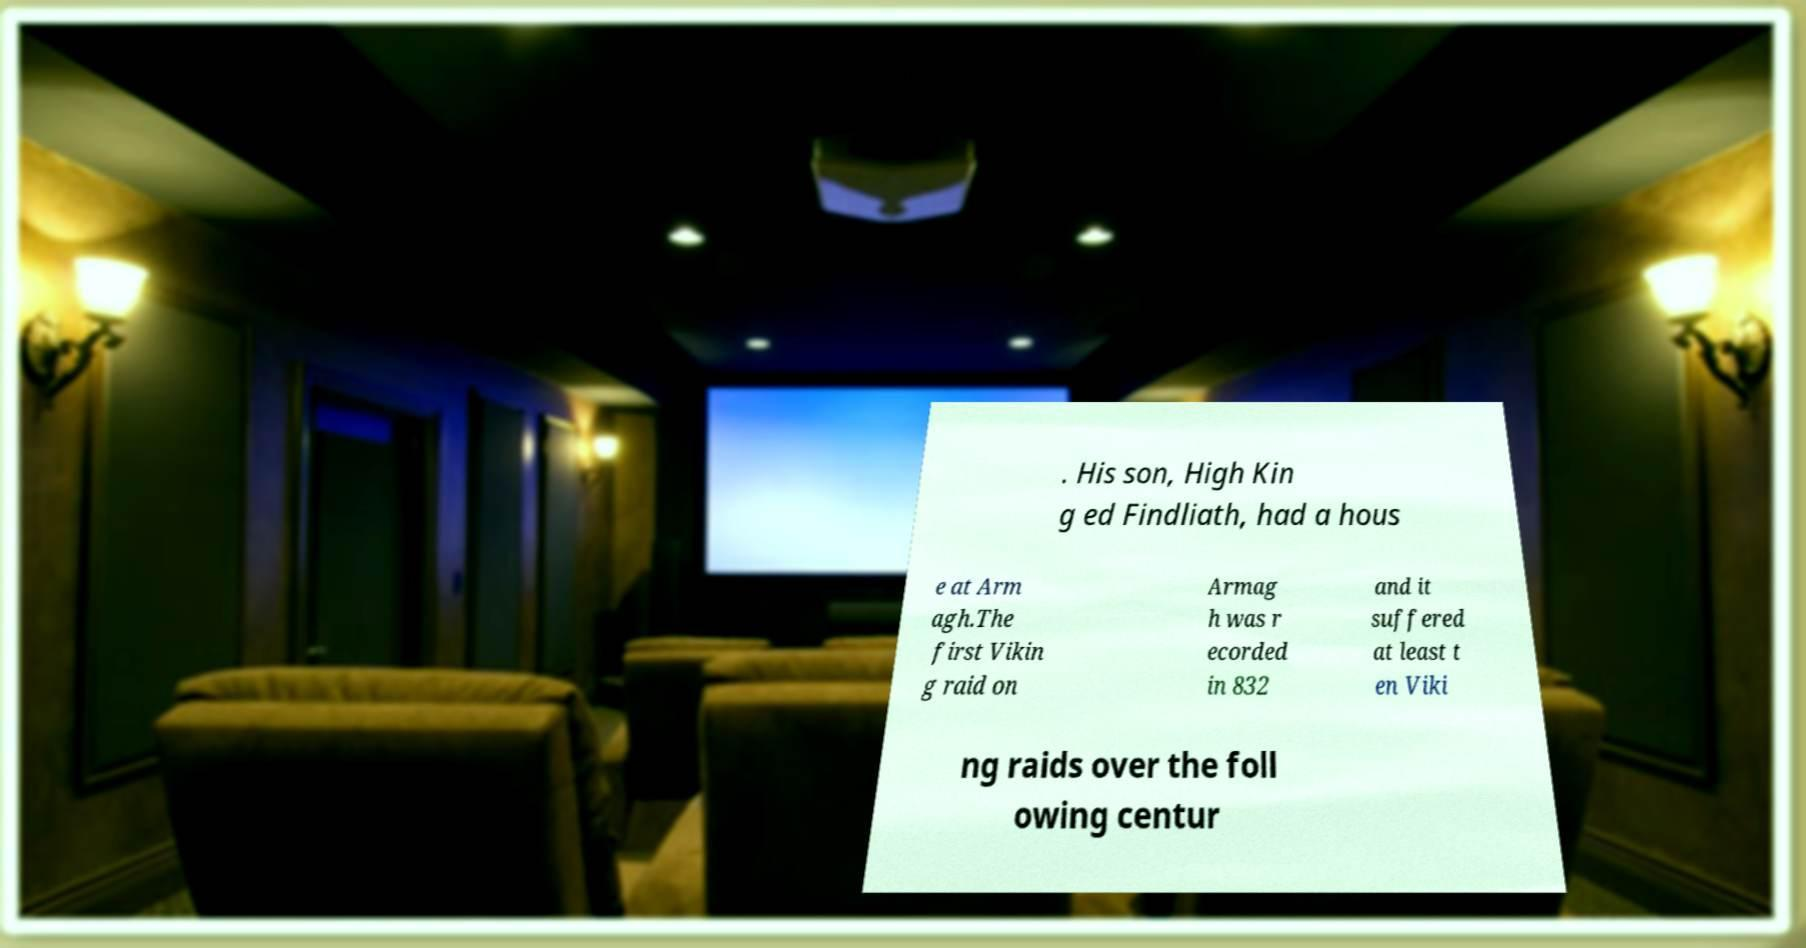Please read and relay the text visible in this image. What does it say? . His son, High Kin g ed Findliath, had a hous e at Arm agh.The first Vikin g raid on Armag h was r ecorded in 832 and it suffered at least t en Viki ng raids over the foll owing centur 